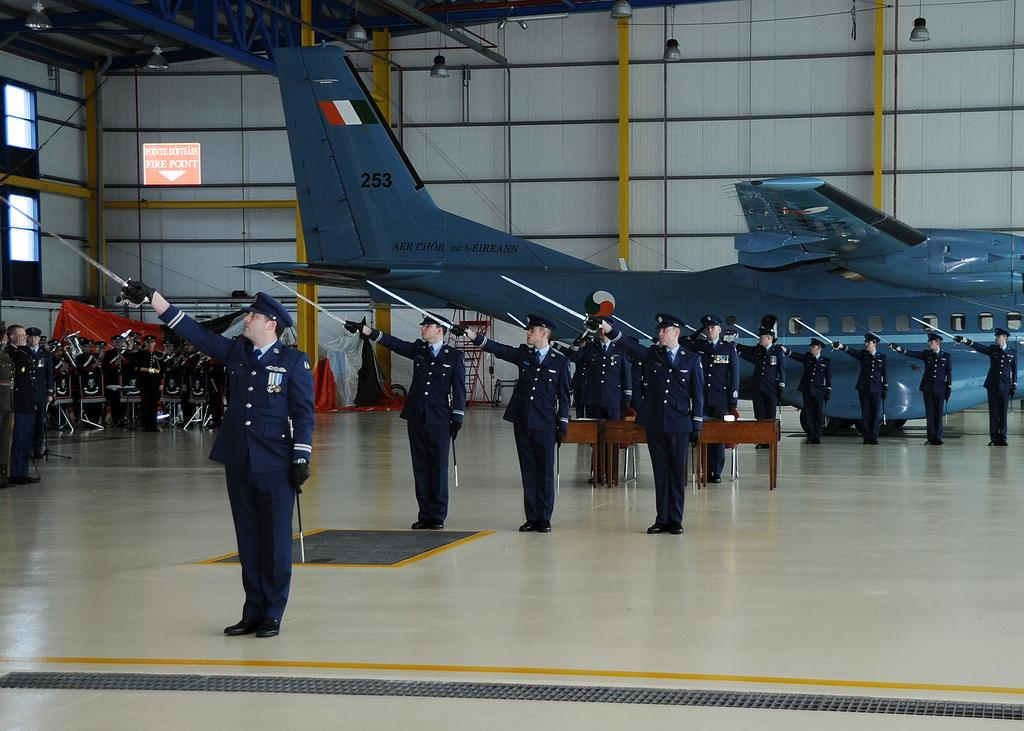<image>
Write a terse but informative summary of the picture. many men in dark blue uniforms are standing in a building by an airplane number 253 